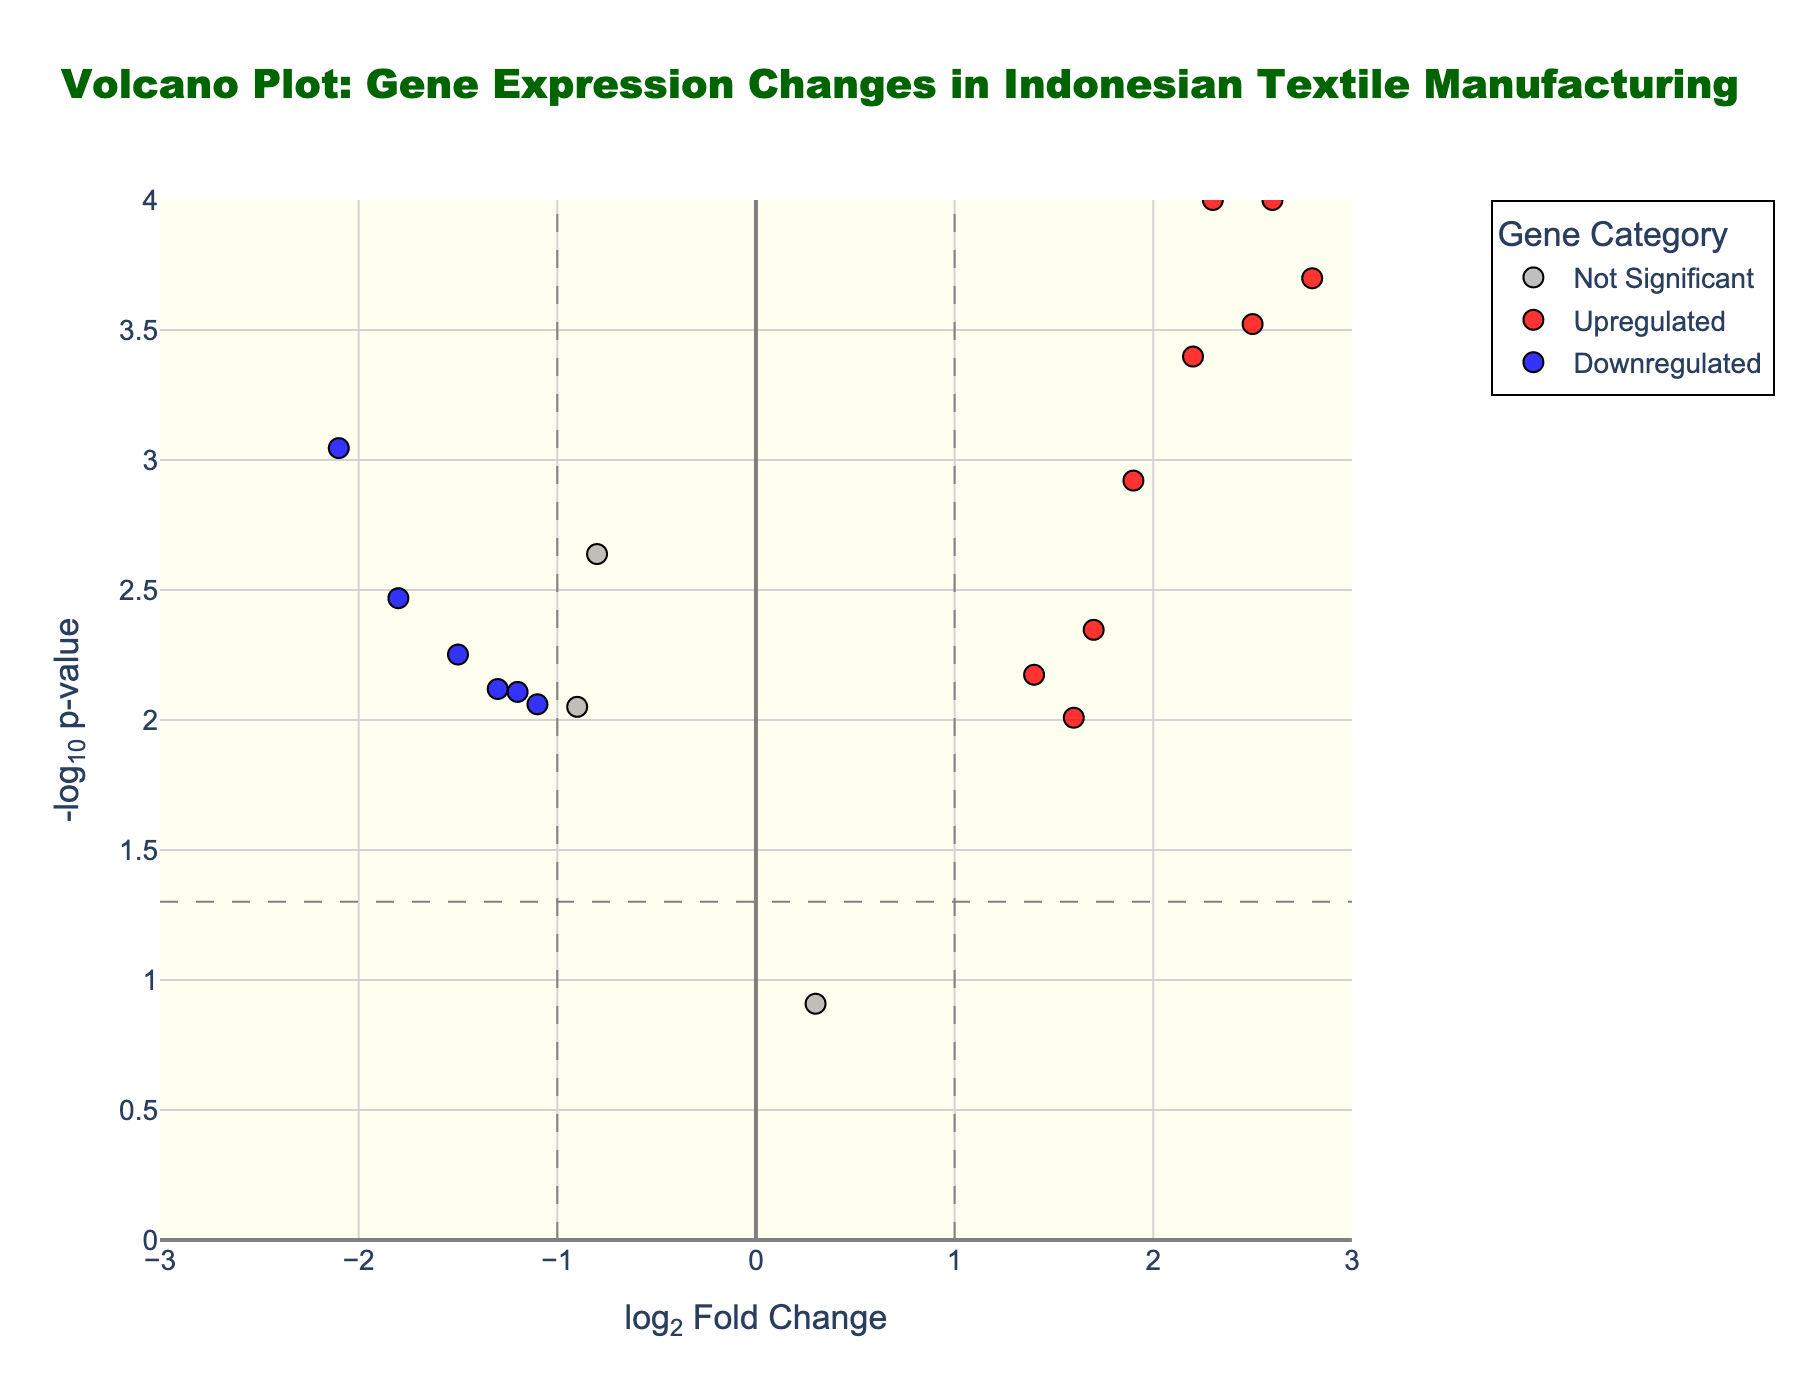Which gene is the most upregulated? By observing the scatter points falling under the 'Upregulated' category and identifying the one with the highest log2FoldChange value, we can determine that MMP1 (log2FoldChange=3.1) is the most upregulated gene.
Answer: MMP1 Which gene has the lowest p-value? By looking at the y-axis which represents -log10(p-value) and identifying the gene with the highest point on this axis, we see that MMP1 has the highest -log10(p-value), indicating the lowest p-value.
Answer: MMP1 Which gene is the most downregulated? By observing the scatter points falling under the 'Downregulated' category and identifying the one with the lowest log2FoldChange value, we can determine that CDH1 (log2FoldChange=-2.1) is the most downregulated gene.
Answer: CDH1 How many genes are significantly upregulated? By identifying the scatter points classified under the 'Upregulated' category, we count the number of such points. From the figure, these points are colored in red. There are 8 genes in this category.
Answer: 8 Does any gene have a log2FoldChange close to zero but is still significant? By identifying the scatter points near log2FoldChange=0 and checking their p-values to see if they fall below the threshold, we see that all points close to zero do not meet the significance criteria given.
Answer: No Which gene is the second most downregulated? By examining the scatter points under the 'Downregulated' category, the second most downregulated gene would be ITGA5 with a log2FoldChange of -1.2, as it has the second lowest value in this category.
Answer: ITGA5 What color represents the "Downregulated" genes? By referring to the legend of the plot, the "Downregulated" genes are represented in blue.
Answer: Blue What is the range of log2FoldChange values presented on the x-axis? By observing the x-axis, it ranges from approximately -3 to 3.
Answer: -3 to 3 What's the significance threshold for p-values in this plot? By identifying the horizontal dashed line indicating the p-value threshold for significance, we see it corresponds to a -log10(p-value) of around 1.301, which translates to a p-value of 0.05.
Answer: 0.05 What is the typical color used to indicate "Upregulated" genes? By referring to the legend of the plot, the "Upregulated" genes are represented in red.
Answer: Red 